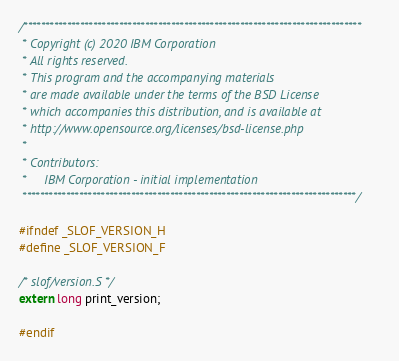<code> <loc_0><loc_0><loc_500><loc_500><_C_>/******************************************************************************
 * Copyright (c) 2020 IBM Corporation
 * All rights reserved.
 * This program and the accompanying materials
 * are made available under the terms of the BSD License
 * which accompanies this distribution, and is available at
 * http://www.opensource.org/licenses/bsd-license.php
 *
 * Contributors:
 *     IBM Corporation - initial implementation
 *****************************************************************************/

#ifndef _SLOF_VERSION_H
#define _SLOF_VERSION_F

/* slof/version.S */
extern long print_version;

#endif
</code> 